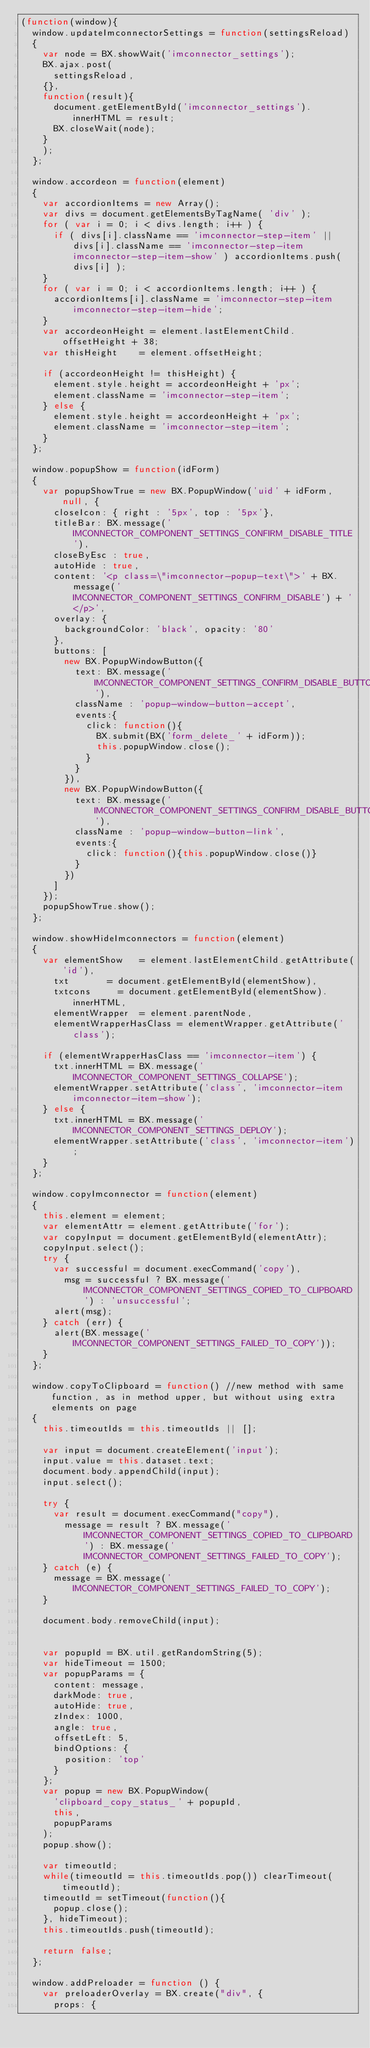<code> <loc_0><loc_0><loc_500><loc_500><_JavaScript_>(function(window){
	window.updateImconnectorSettings = function(settingsReload)
	{
		var node = BX.showWait('imconnector_settings');
		BX.ajax.post(
			settingsReload,
		{},
		function(result){
			document.getElementById('imconnector_settings').innerHTML = result;
			BX.closeWait(node);
		}
		);
	};

	window.accordeon = function(element)
	{
		var accordionItems = new Array();
		var divs = document.getElementsByTagName( 'div' );
		for ( var i = 0; i < divs.length; i++ ) {
			if ( divs[i].className == 'imconnector-step-item' || divs[i].className == 'imconnector-step-item imconnector-step-item-show' ) accordionItems.push( divs[i] );
		}
		for ( var i = 0; i < accordionItems.length; i++ ) {
			accordionItems[i].className = 'imconnector-step-item imconnector-step-item-hide';
		}
		var accordeonHeight = element.lastElementChild.offsetHeight + 38;
		var thisHeight 		= element.offsetHeight;

		if (accordeonHeight != thisHeight) {
			element.style.height = accordeonHeight + 'px';
			element.className = 'imconnector-step-item';
		} else {
			element.style.height = accordeonHeight + 'px';
			element.className = 'imconnector-step-item';
		}
	};

	window.popupShow = function(idForm)
	{
		var popupShowTrue = new BX.PopupWindow('uid' + idForm, null, {
			closeIcon: { right : '5px', top : '5px'},
			titleBar: BX.message('IMCONNECTOR_COMPONENT_SETTINGS_CONFIRM_DISABLE_TITLE'),
			closeByEsc : true,
			autoHide : true,
			content: '<p class=\"imconnector-popup-text\">' + BX.message('IMCONNECTOR_COMPONENT_SETTINGS_CONFIRM_DISABLE') + '</p>',
			overlay: {
				backgroundColor: 'black', opacity: '80'
			},
			buttons: [
				new BX.PopupWindowButton({
					text: BX.message('IMCONNECTOR_COMPONENT_SETTINGS_CONFIRM_DISABLE_BUTTON_OK'),
					className : 'popup-window-button-accept',
					events:{
						click: function(){
							BX.submit(BX('form_delete_' + idForm));
							this.popupWindow.close();
						}
					}
				}),
				new BX.PopupWindowButton({
					text: BX.message('IMCONNECTOR_COMPONENT_SETTINGS_CONFIRM_DISABLE_BUTTON_CANCEL'),
					className : 'popup-window-button-link',
					events:{
						click: function(){this.popupWindow.close()}
					}
				})
			]
		});
		popupShowTrue.show();
	};

	window.showHideImconnectors = function(element)
	{
		var elementShow 	= element.lastElementChild.getAttribute('id'),
			txt 			= document.getElementById(elementShow),
			txtcons 		= document.getElementById(elementShow).innerHTML,
			elementWrapper	= element.parentNode,
			elementWrapperHasClass = elementWrapper.getAttribute('class');

		if (elementWrapperHasClass == 'imconnector-item') {
			txt.innerHTML = BX.message('IMCONNECTOR_COMPONENT_SETTINGS_COLLAPSE');
			elementWrapper.setAttribute('class', 'imconnector-item imconnector-item-show');
		} else {
			txt.innerHTML = BX.message('IMCONNECTOR_COMPONENT_SETTINGS_DEPLOY');
			elementWrapper.setAttribute('class', 'imconnector-item');
		}
	};

	window.copyImconnector = function(element)
	{
		this.element = element;
		var elementAttr = element.getAttribute('for');
		var copyInput = document.getElementById(elementAttr);
		copyInput.select();
		try {
			var successful = document.execCommand('copy'),
				msg = successful ? BX.message('IMCONNECTOR_COMPONENT_SETTINGS_COPIED_TO_CLIPBOARD') : 'unsuccessful';
			alert(msg);
		} catch (err) {
			alert(BX.message('IMCONNECTOR_COMPONENT_SETTINGS_FAILED_TO_COPY'));
		}
	};

	window.copyToClipboard = function() //new method with same function, as in method upper, but without using extra elements on page
	{
		this.timeoutIds = this.timeoutIds || [];

		var input = document.createElement('input');
		input.value = this.dataset.text;
		document.body.appendChild(input);
		input.select();

		try {
			var result = document.execCommand("copy"),
				message = result ? BX.message('IMCONNECTOR_COMPONENT_SETTINGS_COPIED_TO_CLIPBOARD') : BX.message('IMCONNECTOR_COMPONENT_SETTINGS_FAILED_TO_COPY');
		} catch (e) {
			message = BX.message('IMCONNECTOR_COMPONENT_SETTINGS_FAILED_TO_COPY');
		}

		document.body.removeChild(input);


		var popupId = BX.util.getRandomString(5);
		var hideTimeout = 1500;
		var popupParams = {
			content: message,
			darkMode: true,
			autoHide: true,
			zIndex: 1000,
			angle: true,
			offsetLeft: 5,
			bindOptions: {
				position: 'top'
			}
		};
		var popup = new BX.PopupWindow(
			'clipboard_copy_status_' + popupId,
			this,
			popupParams
		);
		popup.show();

		var timeoutId;
		while(timeoutId = this.timeoutIds.pop()) clearTimeout(timeoutId);
		timeoutId = setTimeout(function(){
			popup.close();
		}, hideTimeout);
		this.timeoutIds.push(timeoutId);

		return false;
	};

	window.addPreloader = function () {
		var preloaderOverlay = BX.create("div", {
			props: {</code> 